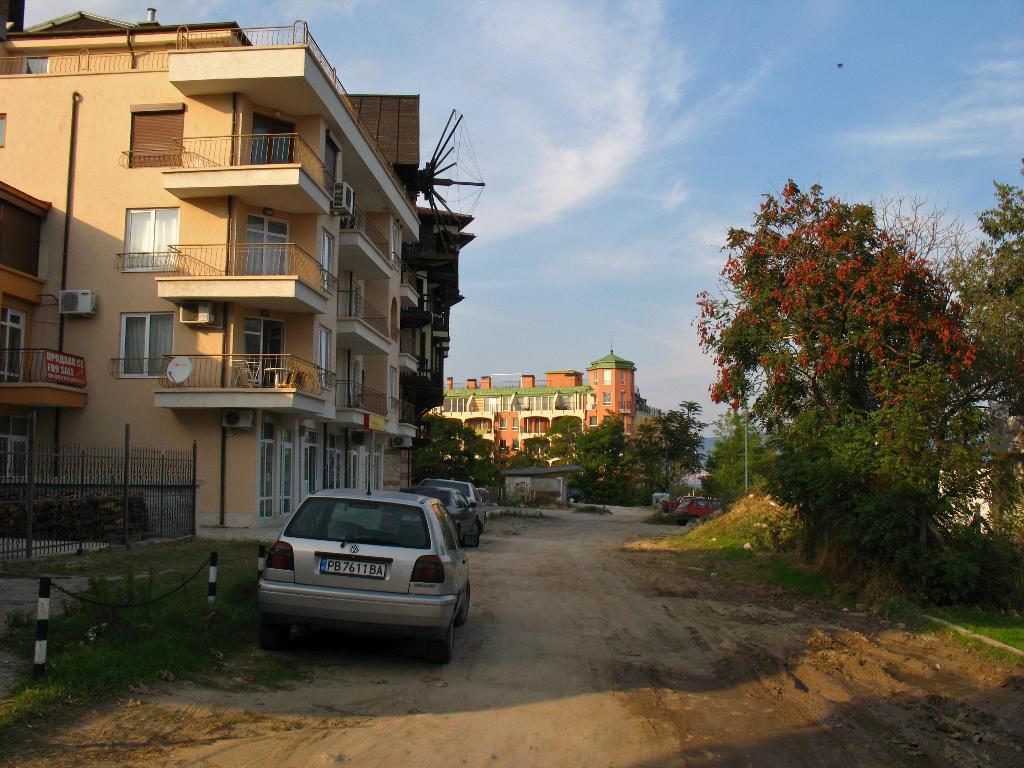Describe this image in one or two sentences. In this picture I can see vehicles on the ground. On the left side I can see buildings, fence and sky. On the right side I can see trees and grass. 